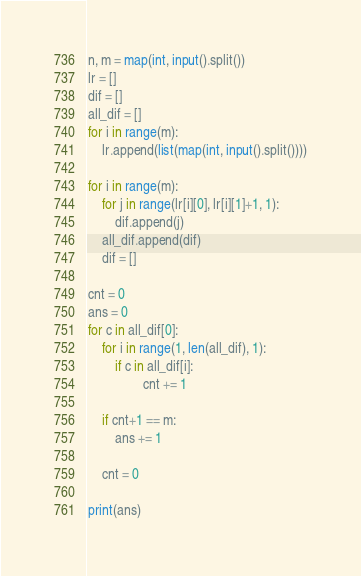<code> <loc_0><loc_0><loc_500><loc_500><_Python_>n, m = map(int, input().split())
lr = []
dif = []
all_dif = []
for i in range(m):
    lr.append(list(map(int, input().split())))

for i in range(m):
    for j in range(lr[i][0], lr[i][1]+1, 1):
        dif.append(j)
    all_dif.append(dif)
    dif = []

cnt = 0
ans = 0
for c in all_dif[0]:
    for i in range(1, len(all_dif), 1):
        if c in all_dif[i]:
                cnt += 1

    if cnt+1 == m:
        ans += 1

    cnt = 0

print(ans)</code> 